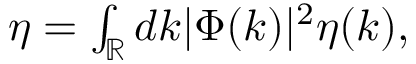<formula> <loc_0><loc_0><loc_500><loc_500>\begin{array} { r } { \eta = \int _ { \mathbb { R } } d k | \Phi ( k ) | ^ { 2 } \eta ( k ) , } \end{array}</formula> 